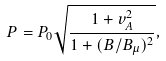Convert formula to latex. <formula><loc_0><loc_0><loc_500><loc_500>P = P _ { 0 } \sqrt { \frac { 1 + v _ { A } ^ { 2 } } { 1 + ( B / B _ { \mu } ) ^ { 2 } } } ,</formula> 